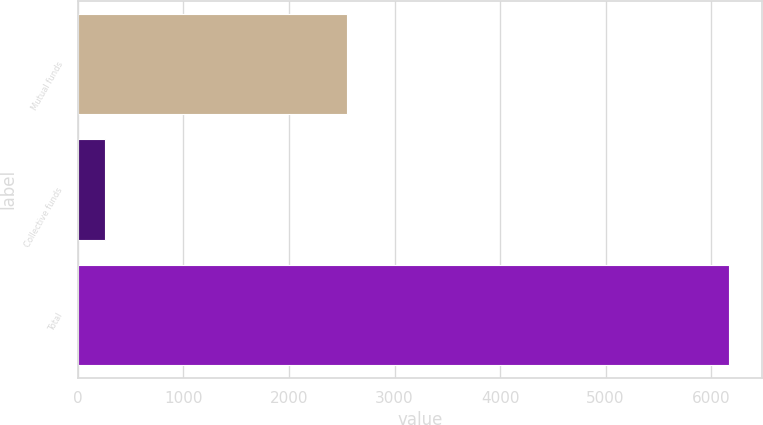<chart> <loc_0><loc_0><loc_500><loc_500><bar_chart><fcel>Mutual funds<fcel>Collective funds<fcel>Total<nl><fcel>2548<fcel>260<fcel>6171<nl></chart> 